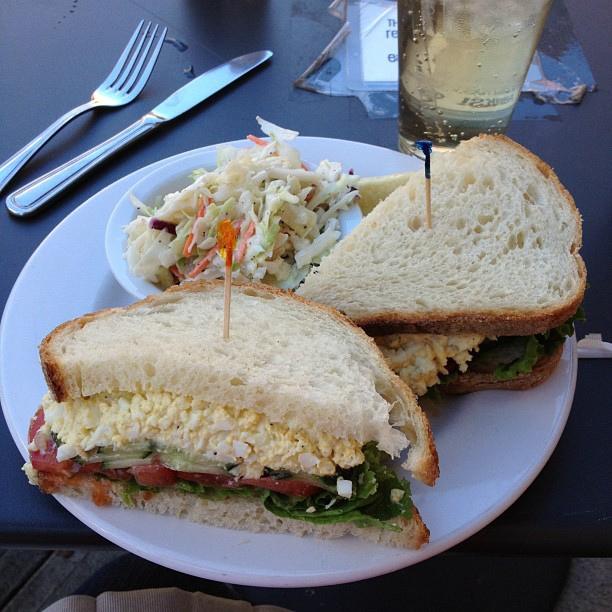How many utensils are there?
Short answer required. 2. What kind of salad is there?
Write a very short answer. Egg. What color is the plate?
Quick response, please. White. What type of egg is this?
Be succinct. Egg salad. 